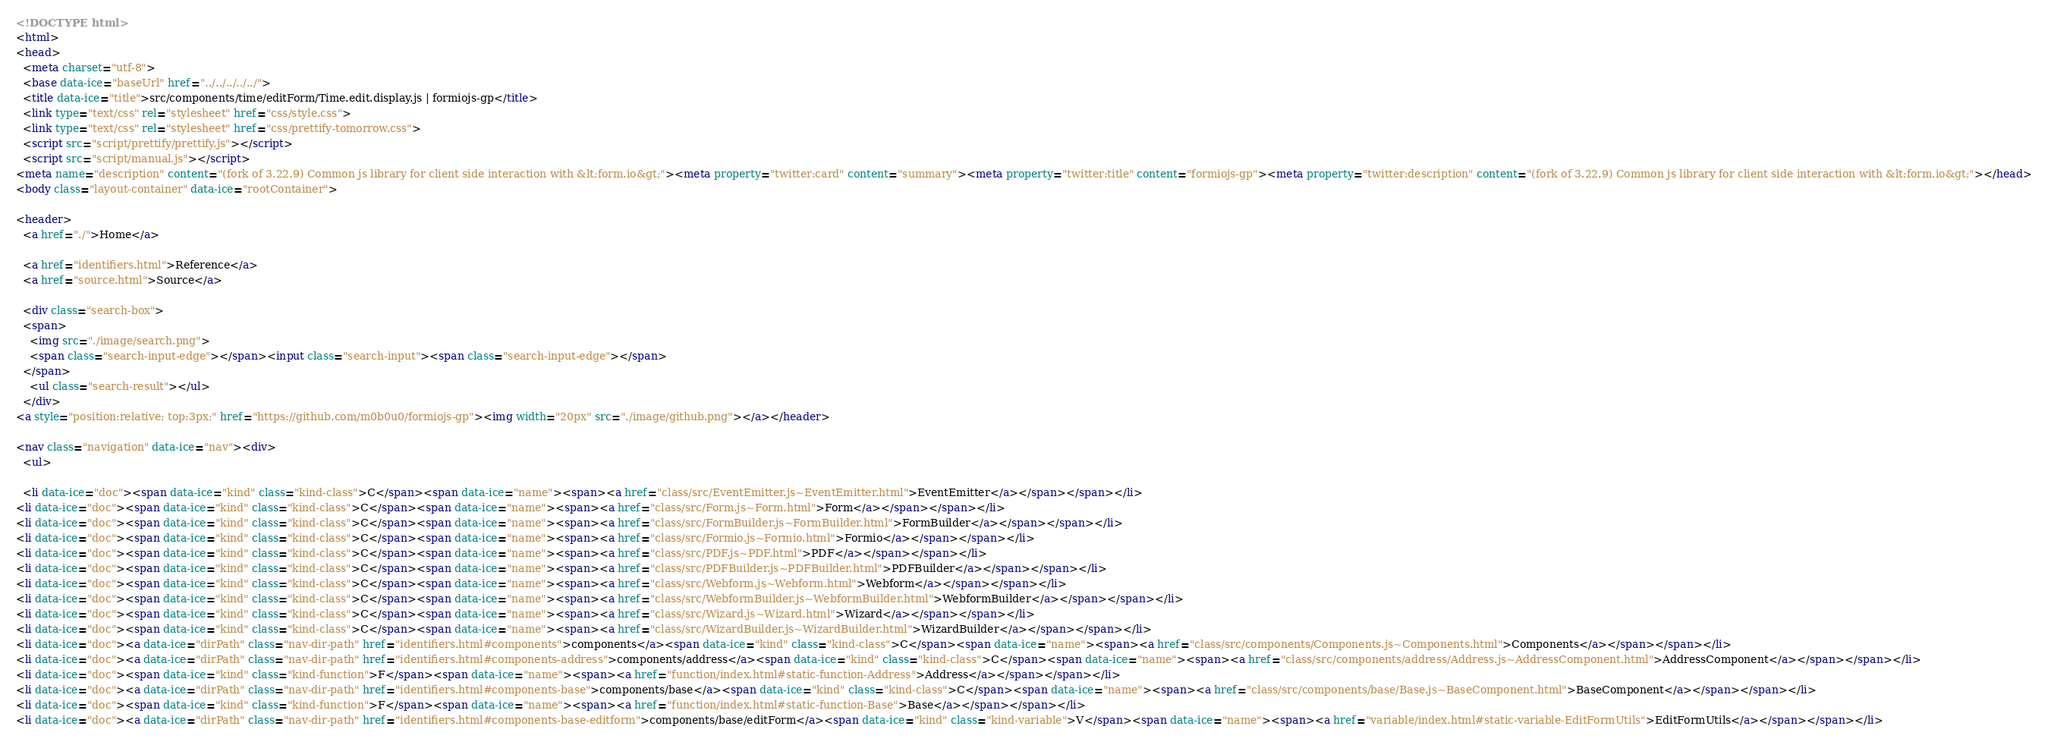Convert code to text. <code><loc_0><loc_0><loc_500><loc_500><_HTML_><!DOCTYPE html>
<html>
<head>
  <meta charset="utf-8">
  <base data-ice="baseUrl" href="../../../../../">
  <title data-ice="title">src/components/time/editForm/Time.edit.display.js | formiojs-gp</title>
  <link type="text/css" rel="stylesheet" href="css/style.css">
  <link type="text/css" rel="stylesheet" href="css/prettify-tomorrow.css">
  <script src="script/prettify/prettify.js"></script>
  <script src="script/manual.js"></script>
<meta name="description" content="(fork of 3.22.9) Common js library for client side interaction with &lt;form.io&gt;"><meta property="twitter:card" content="summary"><meta property="twitter:title" content="formiojs-gp"><meta property="twitter:description" content="(fork of 3.22.9) Common js library for client side interaction with &lt;form.io&gt;"></head>
<body class="layout-container" data-ice="rootContainer">

<header>
  <a href="./">Home</a>
  
  <a href="identifiers.html">Reference</a>
  <a href="source.html">Source</a>
  
  <div class="search-box">
  <span>
    <img src="./image/search.png">
    <span class="search-input-edge"></span><input class="search-input"><span class="search-input-edge"></span>
  </span>
    <ul class="search-result"></ul>
  </div>
<a style="position:relative; top:3px;" href="https://github.com/m0b0u0/formiojs-gp"><img width="20px" src="./image/github.png"></a></header>

<nav class="navigation" data-ice="nav"><div>
  <ul>
    
  <li data-ice="doc"><span data-ice="kind" class="kind-class">C</span><span data-ice="name"><span><a href="class/src/EventEmitter.js~EventEmitter.html">EventEmitter</a></span></span></li>
<li data-ice="doc"><span data-ice="kind" class="kind-class">C</span><span data-ice="name"><span><a href="class/src/Form.js~Form.html">Form</a></span></span></li>
<li data-ice="doc"><span data-ice="kind" class="kind-class">C</span><span data-ice="name"><span><a href="class/src/FormBuilder.js~FormBuilder.html">FormBuilder</a></span></span></li>
<li data-ice="doc"><span data-ice="kind" class="kind-class">C</span><span data-ice="name"><span><a href="class/src/Formio.js~Formio.html">Formio</a></span></span></li>
<li data-ice="doc"><span data-ice="kind" class="kind-class">C</span><span data-ice="name"><span><a href="class/src/PDF.js~PDF.html">PDF</a></span></span></li>
<li data-ice="doc"><span data-ice="kind" class="kind-class">C</span><span data-ice="name"><span><a href="class/src/PDFBuilder.js~PDFBuilder.html">PDFBuilder</a></span></span></li>
<li data-ice="doc"><span data-ice="kind" class="kind-class">C</span><span data-ice="name"><span><a href="class/src/Webform.js~Webform.html">Webform</a></span></span></li>
<li data-ice="doc"><span data-ice="kind" class="kind-class">C</span><span data-ice="name"><span><a href="class/src/WebformBuilder.js~WebformBuilder.html">WebformBuilder</a></span></span></li>
<li data-ice="doc"><span data-ice="kind" class="kind-class">C</span><span data-ice="name"><span><a href="class/src/Wizard.js~Wizard.html">Wizard</a></span></span></li>
<li data-ice="doc"><span data-ice="kind" class="kind-class">C</span><span data-ice="name"><span><a href="class/src/WizardBuilder.js~WizardBuilder.html">WizardBuilder</a></span></span></li>
<li data-ice="doc"><a data-ice="dirPath" class="nav-dir-path" href="identifiers.html#components">components</a><span data-ice="kind" class="kind-class">C</span><span data-ice="name"><span><a href="class/src/components/Components.js~Components.html">Components</a></span></span></li>
<li data-ice="doc"><a data-ice="dirPath" class="nav-dir-path" href="identifiers.html#components-address">components/address</a><span data-ice="kind" class="kind-class">C</span><span data-ice="name"><span><a href="class/src/components/address/Address.js~AddressComponent.html">AddressComponent</a></span></span></li>
<li data-ice="doc"><span data-ice="kind" class="kind-function">F</span><span data-ice="name"><span><a href="function/index.html#static-function-Address">Address</a></span></span></li>
<li data-ice="doc"><a data-ice="dirPath" class="nav-dir-path" href="identifiers.html#components-base">components/base</a><span data-ice="kind" class="kind-class">C</span><span data-ice="name"><span><a href="class/src/components/base/Base.js~BaseComponent.html">BaseComponent</a></span></span></li>
<li data-ice="doc"><span data-ice="kind" class="kind-function">F</span><span data-ice="name"><span><a href="function/index.html#static-function-Base">Base</a></span></span></li>
<li data-ice="doc"><a data-ice="dirPath" class="nav-dir-path" href="identifiers.html#components-base-editform">components/base/editForm</a><span data-ice="kind" class="kind-variable">V</span><span data-ice="name"><span><a href="variable/index.html#static-variable-EditFormUtils">EditFormUtils</a></span></span></li></code> 